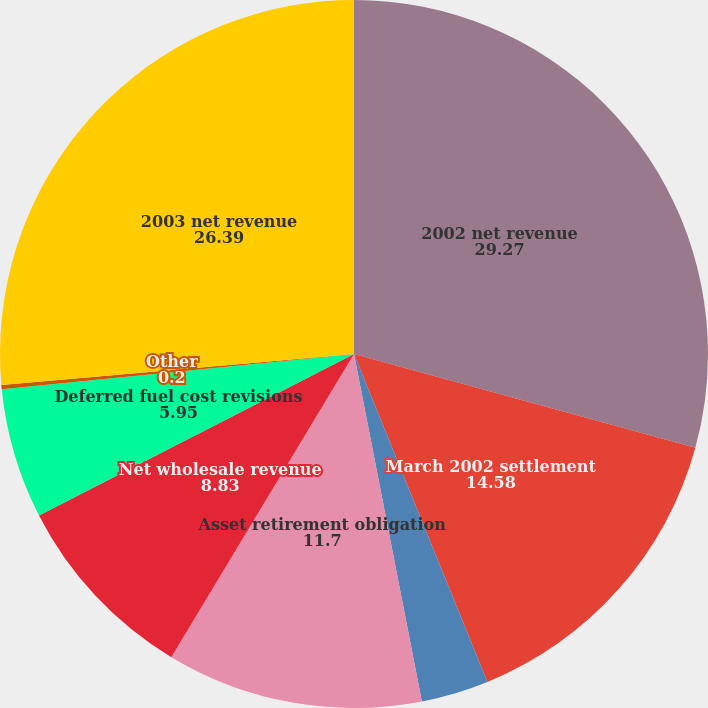<chart> <loc_0><loc_0><loc_500><loc_500><pie_chart><fcel>2002 net revenue<fcel>March 2002 settlement<fcel>Volume/weather<fcel>Asset retirement obligation<fcel>Net wholesale revenue<fcel>Deferred fuel cost revisions<fcel>Other<fcel>2003 net revenue<nl><fcel>29.27%<fcel>14.58%<fcel>3.08%<fcel>11.7%<fcel>8.83%<fcel>5.95%<fcel>0.2%<fcel>26.39%<nl></chart> 